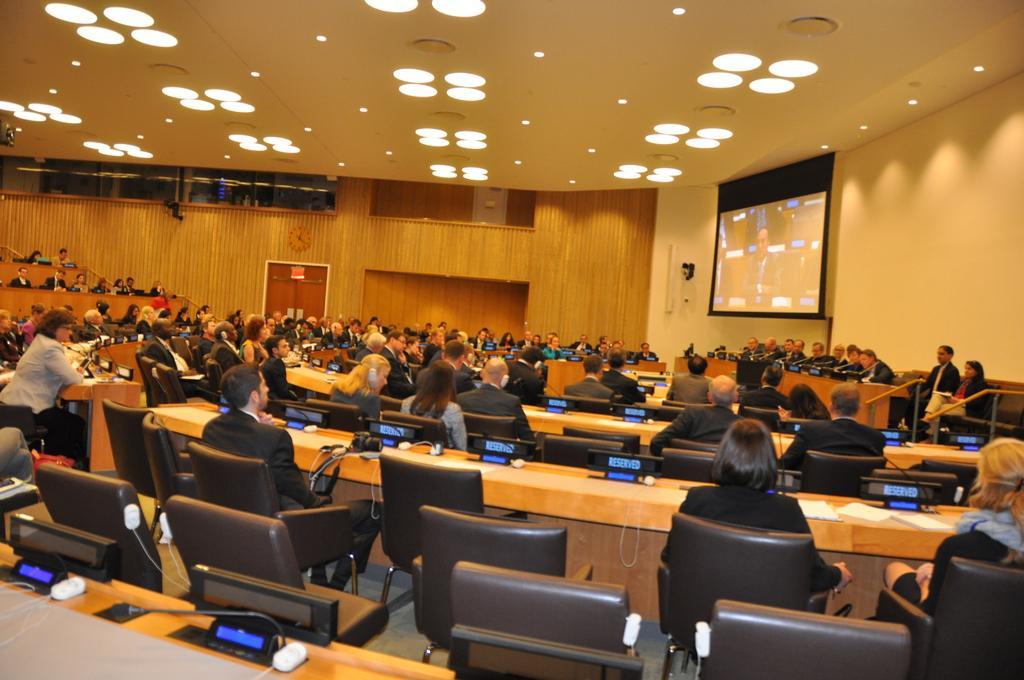Can you describe this image briefly? This is an image clicked inside the room. It seems to be like a seminar hall. There are number of chairs and tables hire. On the right side of the wall there is a screen. On the top of the image there are some lights. Everyone are sitting on the chairs and looking at the screen. 